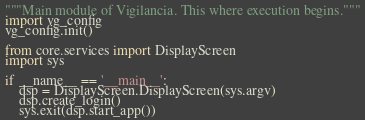Convert code to text. <code><loc_0><loc_0><loc_500><loc_500><_Python_>"""Main module of Vigilancia. This where execution begins."""
import vg_config
vg_config.init()

from core.services import DisplayScreen
import sys

if __name__ == '__main__':
    dsp = DisplayScreen.DisplayScreen(sys.argv)
    dsp.create_login()
    sys.exit(dsp.start_app())
</code> 